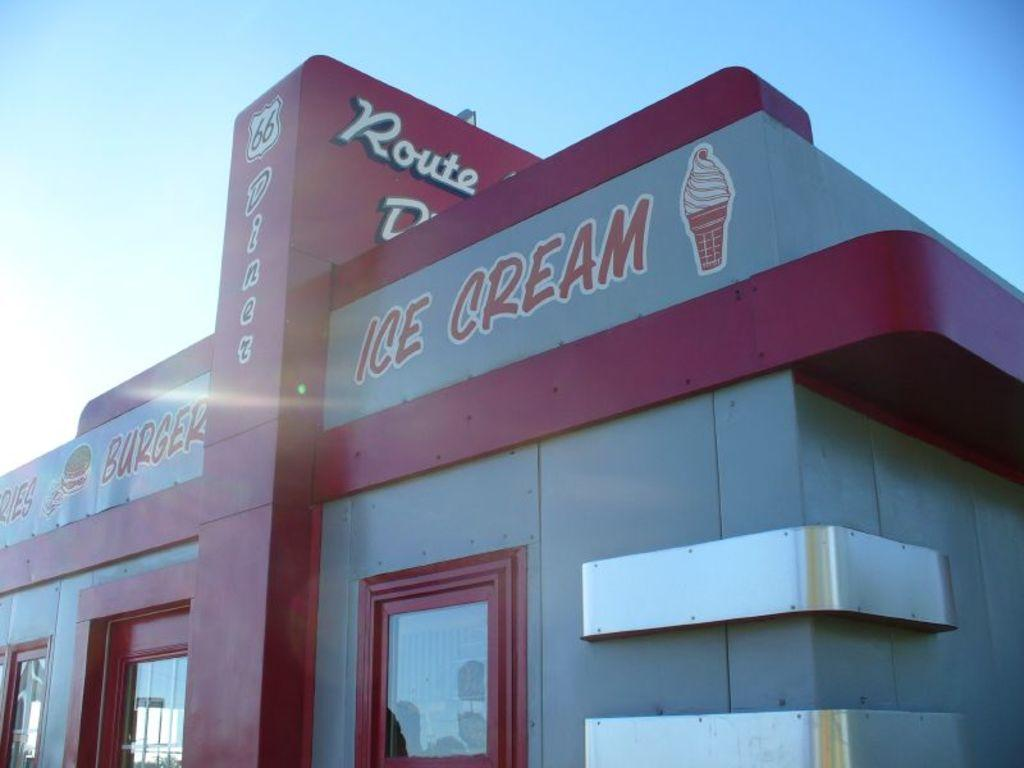What type of structure can be seen in the image? There is a building in the image. Can you describe any specific features of the building? There is text visible on the building. What type of bait is being used to catch fish in the image? There is no mention of fish or bait in the image; it only features a building with text on it. 